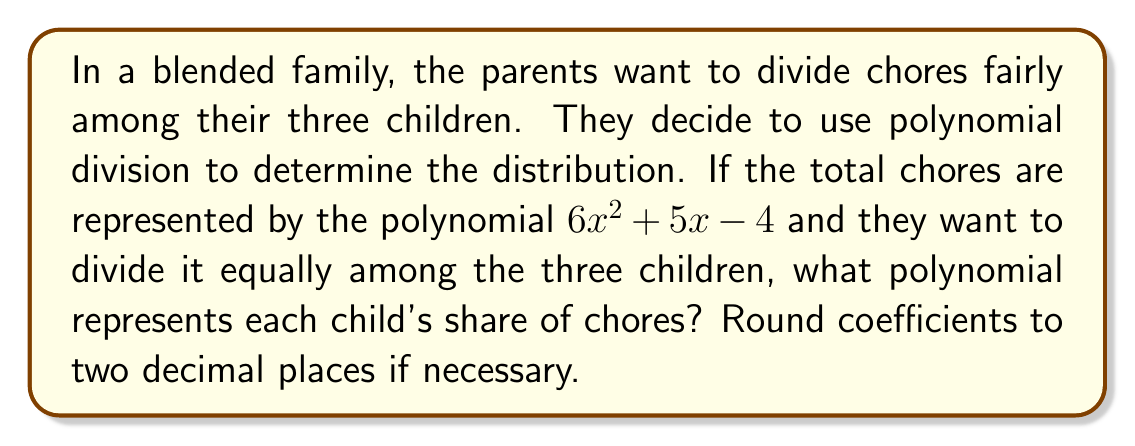What is the answer to this math problem? To solve this problem, we need to divide the given polynomial by 3. Let's perform polynomial long division:

$$(6x^2 + 5x - 4) \div 3$$

1) First, divide the leading term:
   $6x^2 \div 3 = 2x^2$

2) Multiply the result by 3 and subtract:
   $$6x^2 + 5x - 4$$
   $$-(6x^2)$$
   $$5x - 4$$

3) Bring down the next term and divide:
   $5x \div 3 = \frac{5}{3}x \approx 1.67x$

4) Multiply the result by 3 and subtract:
   $$5x - 4$$
   $$-(5x)$$
   $$-4$$

5) Divide the constant term:
   $-4 \div 3 = -\frac{4}{3} \approx -1.33$

Therefore, each child's share of chores can be represented by the polynomial:

$$2x^2 + 1.67x - 1.33$$

This means each child is responsible for 2 complex chores (represented by $x^2$), 1.67 medium chores (represented by $x$), and -1.33 simple chores (the negative constant suggests they might earn a small break or reward).
Answer: $2x^2 + 1.67x - 1.33$ 